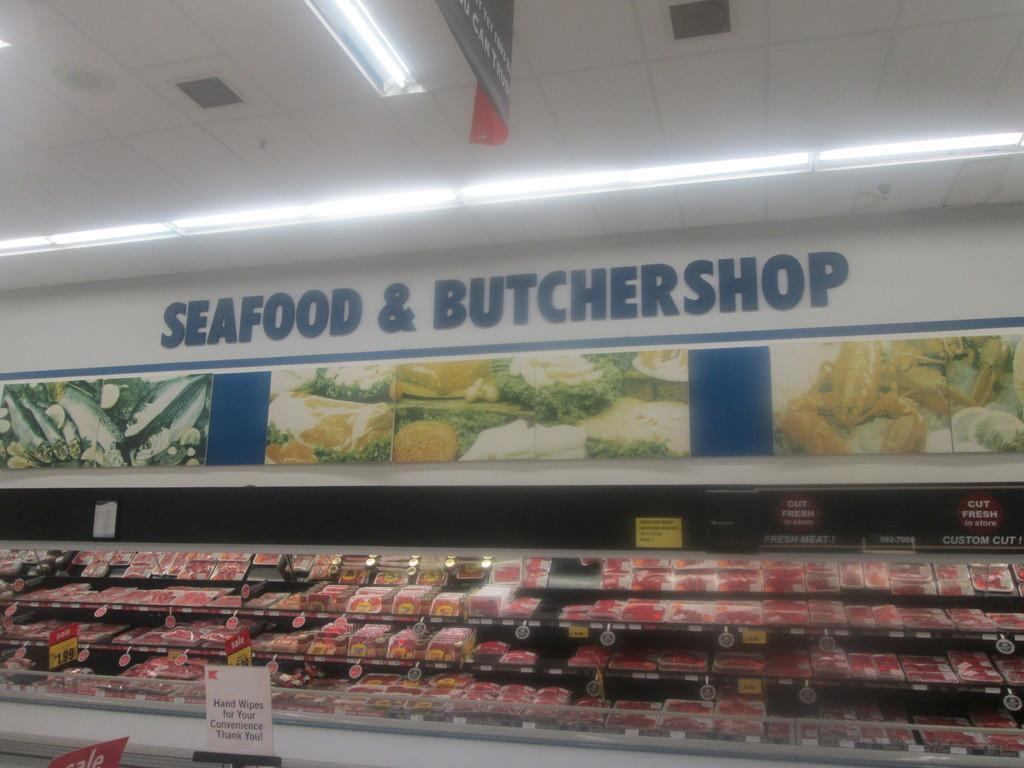<image>
Offer a succinct explanation of the picture presented. A display of meat under a sign reading Seafood and ButcherShop 